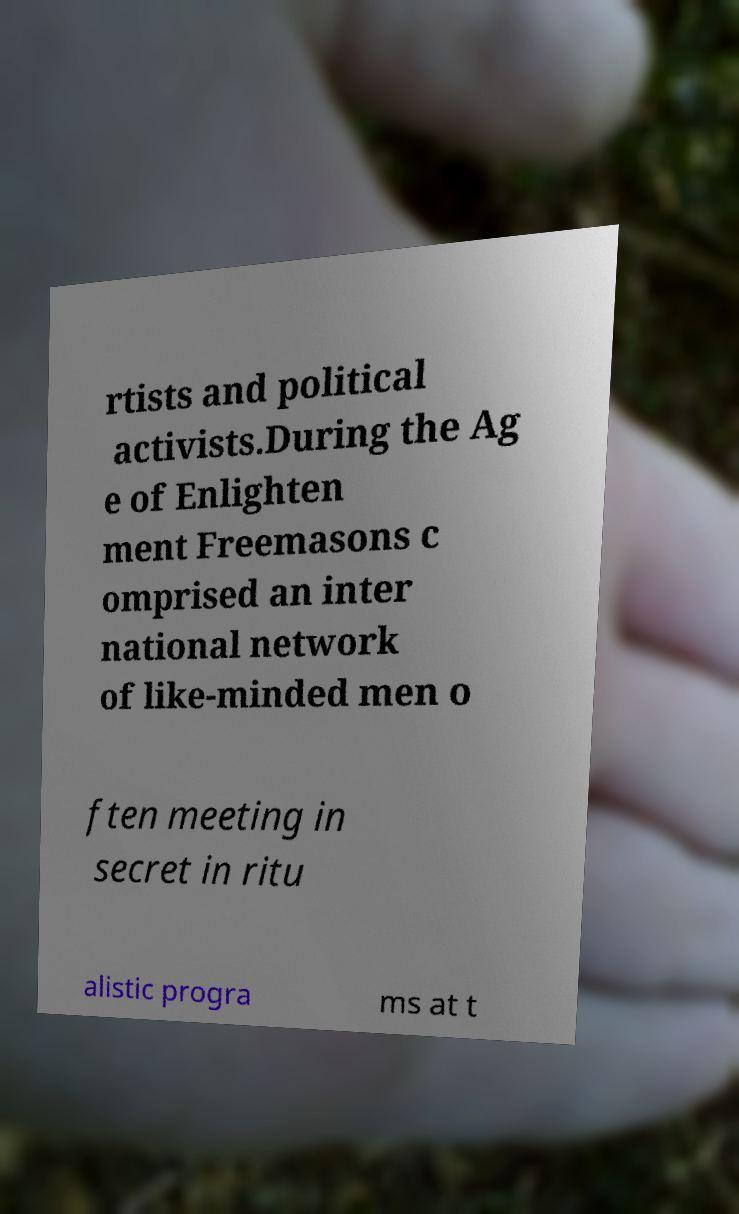Could you assist in decoding the text presented in this image and type it out clearly? rtists and political activists.During the Ag e of Enlighten ment Freemasons c omprised an inter national network of like-minded men o ften meeting in secret in ritu alistic progra ms at t 